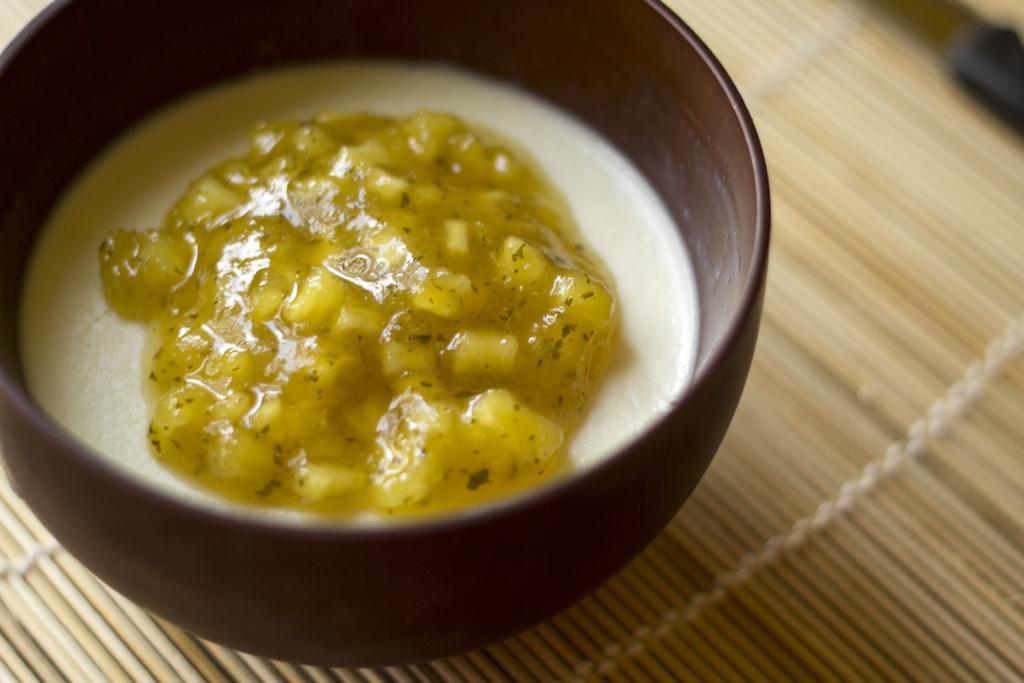Could you give a brief overview of what you see in this image? In this image I can see a brown colour bowl and in it I can see yellow and white colour thing. I can also see cream colour surface under the bowl. 